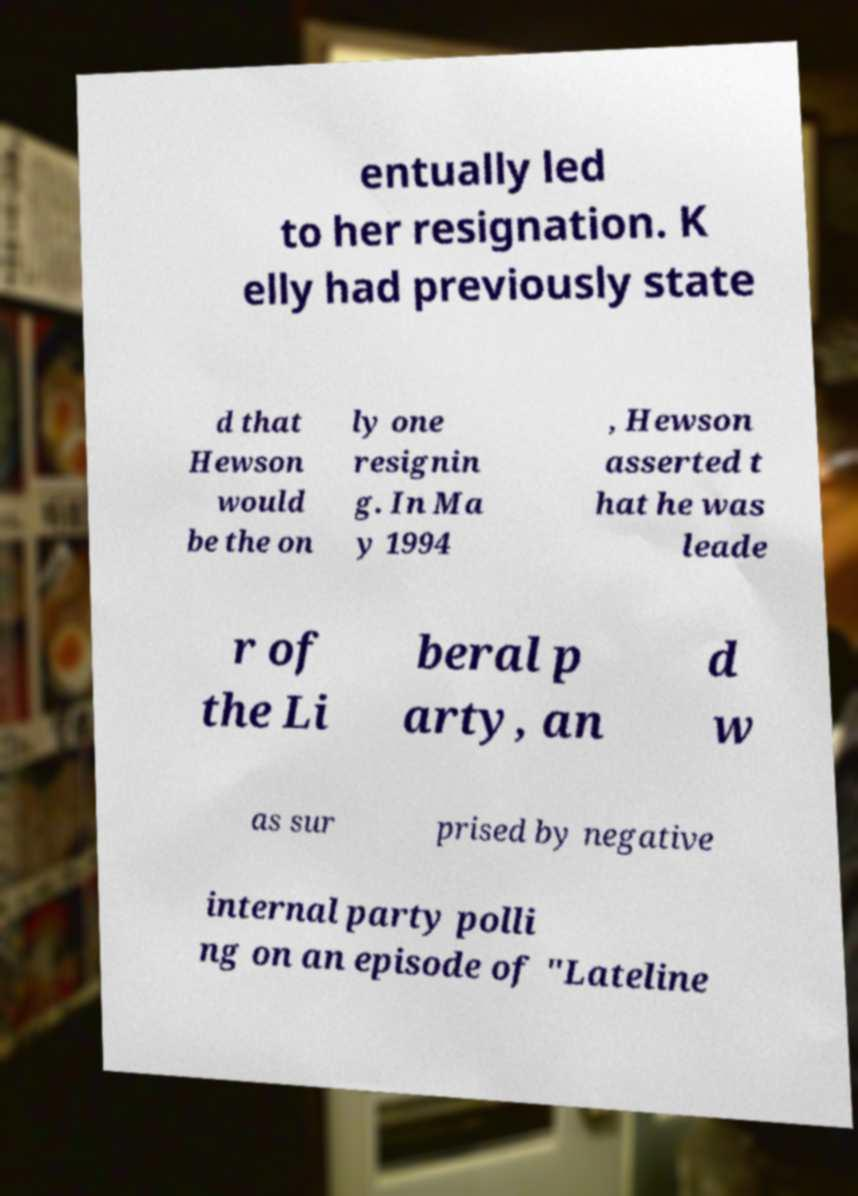Can you accurately transcribe the text from the provided image for me? entually led to her resignation. K elly had previously state d that Hewson would be the on ly one resignin g. In Ma y 1994 , Hewson asserted t hat he was leade r of the Li beral p arty, an d w as sur prised by negative internal party polli ng on an episode of "Lateline 